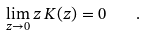Convert formula to latex. <formula><loc_0><loc_0><loc_500><loc_500>\lim _ { z \to 0 } z \, K ( z ) = 0 \quad .</formula> 